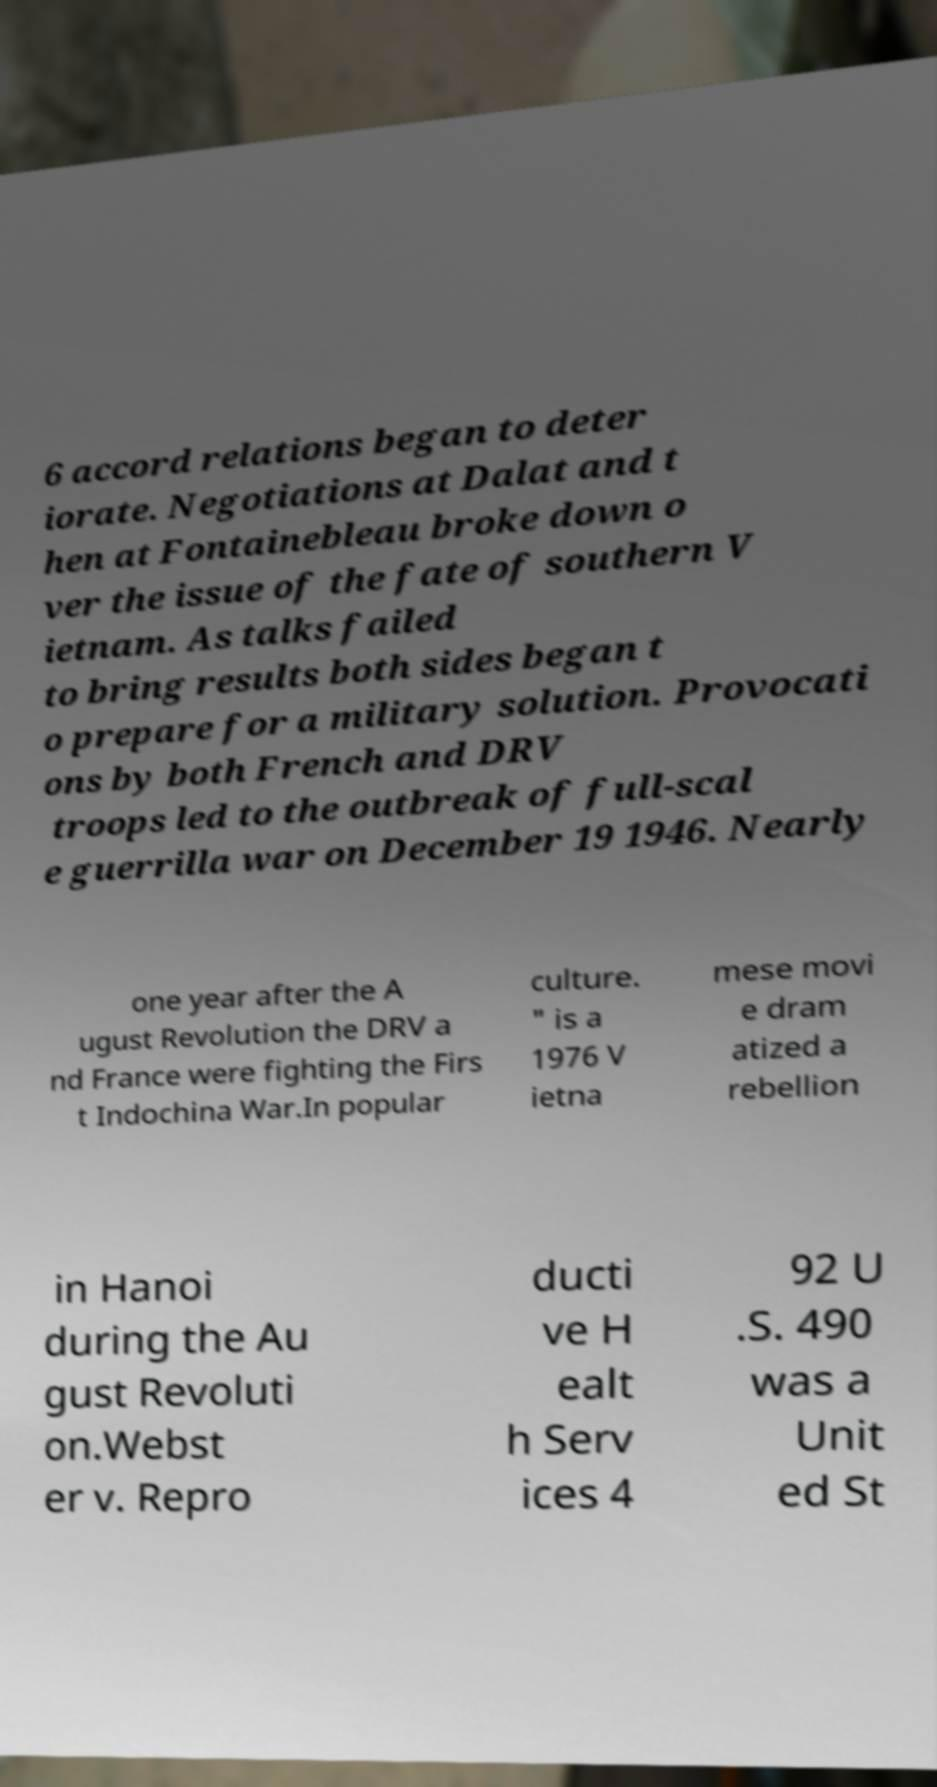Can you read and provide the text displayed in the image?This photo seems to have some interesting text. Can you extract and type it out for me? 6 accord relations began to deter iorate. Negotiations at Dalat and t hen at Fontainebleau broke down o ver the issue of the fate of southern V ietnam. As talks failed to bring results both sides began t o prepare for a military solution. Provocati ons by both French and DRV troops led to the outbreak of full-scal e guerrilla war on December 19 1946. Nearly one year after the A ugust Revolution the DRV a nd France were fighting the Firs t Indochina War.In popular culture. " is a 1976 V ietna mese movi e dram atized a rebellion in Hanoi during the Au gust Revoluti on.Webst er v. Repro ducti ve H ealt h Serv ices 4 92 U .S. 490 was a Unit ed St 